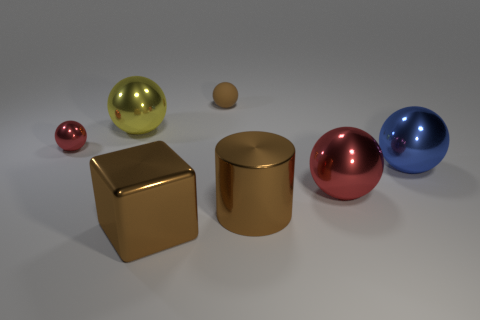Subtract all tiny red spheres. How many spheres are left? 4 Subtract all yellow balls. How many balls are left? 4 Subtract all green balls. Subtract all green cubes. How many balls are left? 5 Add 2 cyan metallic blocks. How many objects exist? 9 Subtract all spheres. How many objects are left? 2 Add 1 big cyan objects. How many big cyan objects exist? 1 Subtract 0 red cylinders. How many objects are left? 7 Subtract all large red shiny spheres. Subtract all brown shiny objects. How many objects are left? 4 Add 1 spheres. How many spheres are left? 6 